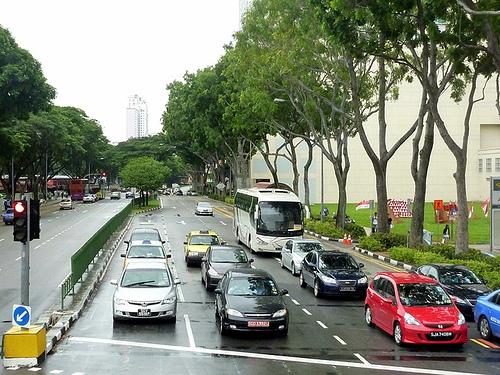<image>
Can you confirm if the signal is behind the bus? No. The signal is not behind the bus. From this viewpoint, the signal appears to be positioned elsewhere in the scene. Where is the bus in relation to the skyscraper? Is it to the right of the skyscraper? No. The bus is not to the right of the skyscraper. The horizontal positioning shows a different relationship. 